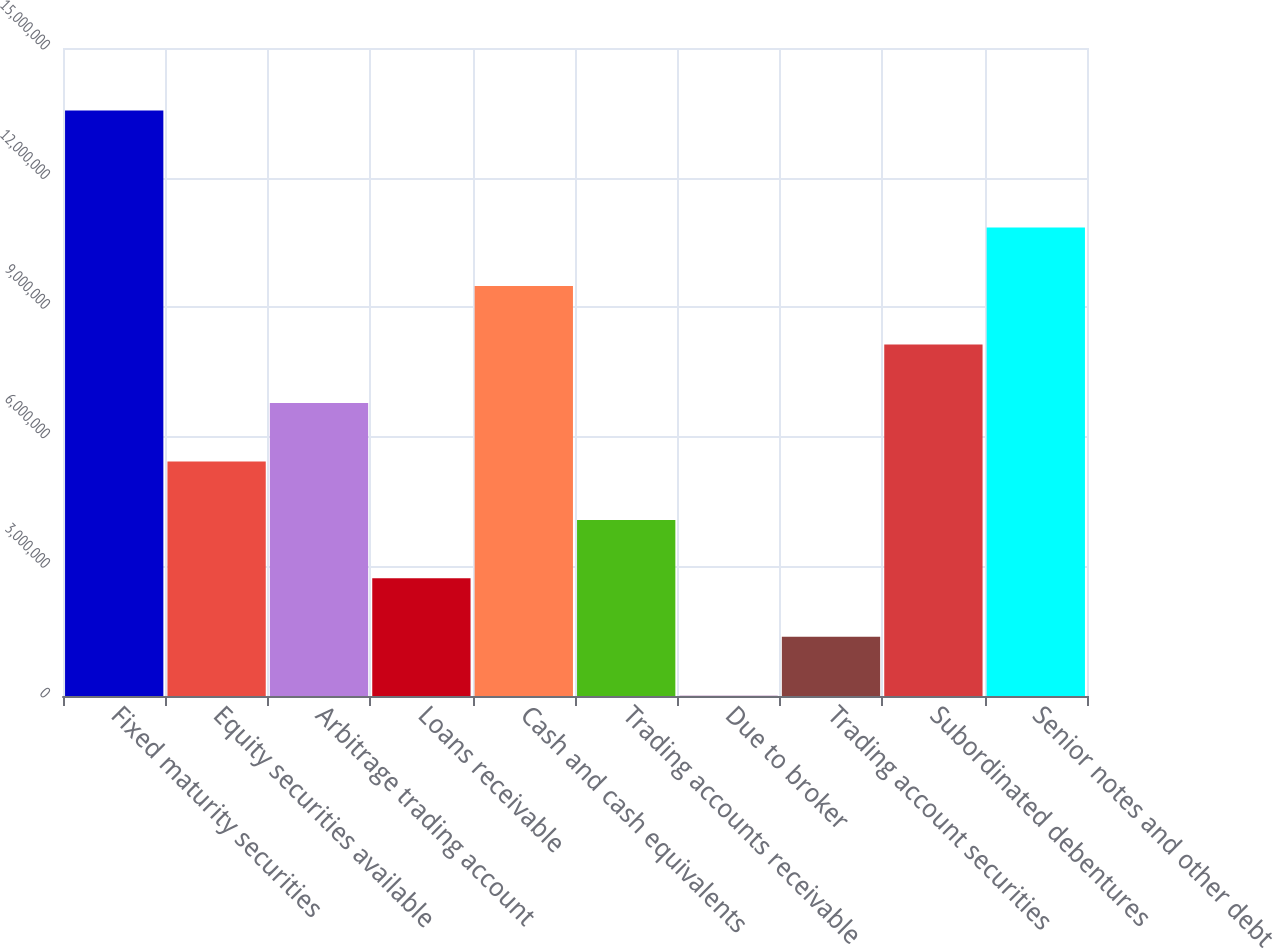Convert chart. <chart><loc_0><loc_0><loc_500><loc_500><bar_chart><fcel>Fixed maturity securities<fcel>Equity securities available<fcel>Arbitrage trading account<fcel>Loans receivable<fcel>Cash and cash equivalents<fcel>Trading accounts receivable<fcel>Due to broker<fcel>Trading account securities<fcel>Subordinated debentures<fcel>Senior notes and other debt<nl><fcel>1.35512e+07<fcel>5.43005e+06<fcel>6.78358e+06<fcel>2.72299e+06<fcel>9.49065e+06<fcel>4.07652e+06<fcel>15920<fcel>1.36945e+06<fcel>8.13712e+06<fcel>1.08442e+07<nl></chart> 